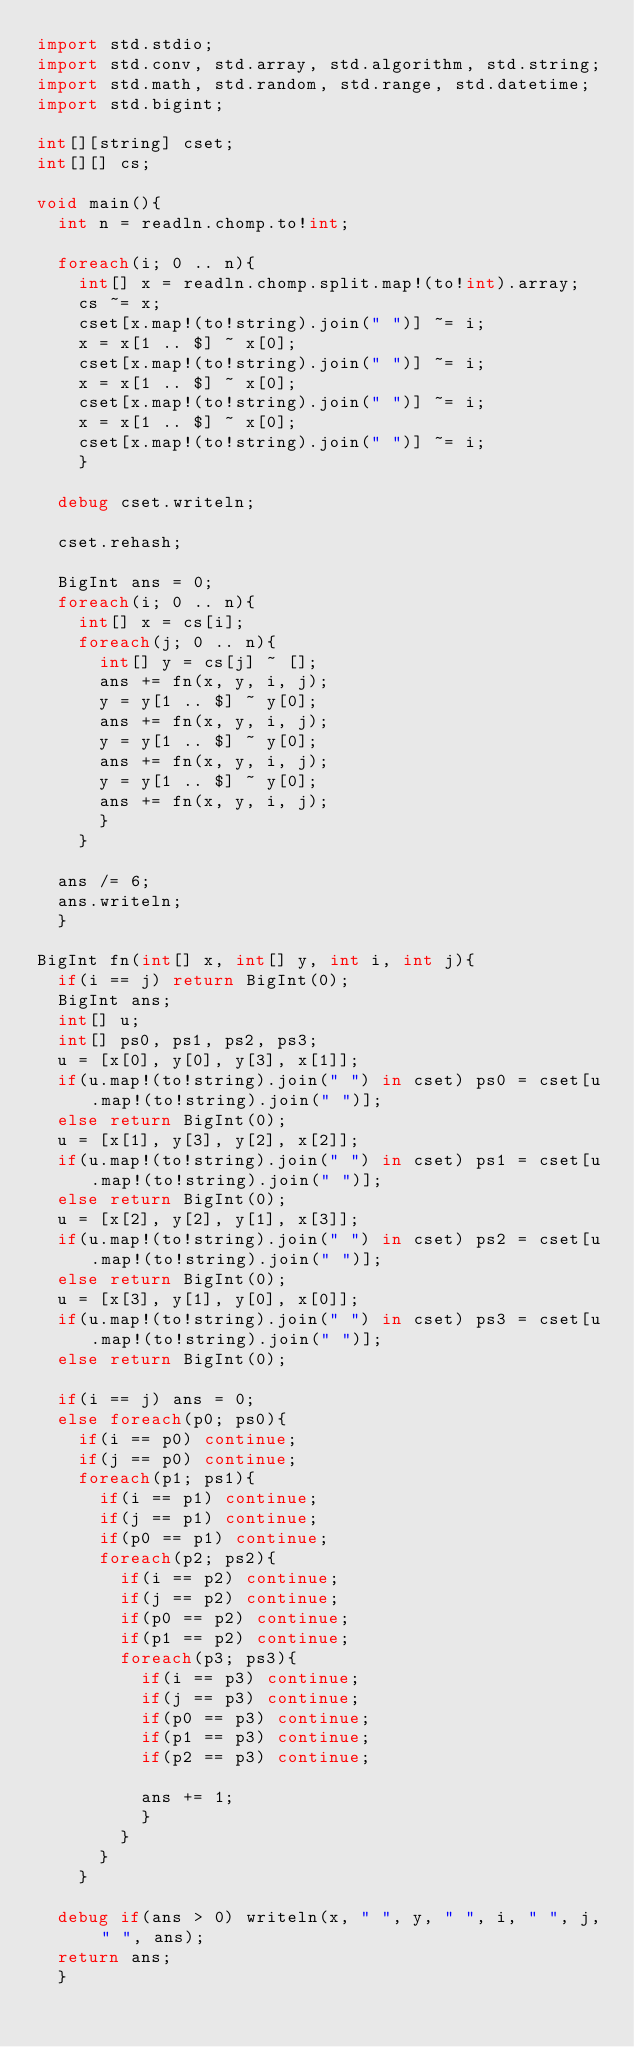Convert code to text. <code><loc_0><loc_0><loc_500><loc_500><_D_>import std.stdio;
import std.conv, std.array, std.algorithm, std.string;
import std.math, std.random, std.range, std.datetime;
import std.bigint;

int[][string] cset;
int[][] cs;

void main(){
	int n = readln.chomp.to!int;
	
	foreach(i; 0 .. n){
		int[] x = readln.chomp.split.map!(to!int).array;
		cs ~= x;
		cset[x.map!(to!string).join(" ")] ~= i;
		x = x[1 .. $] ~ x[0];
		cset[x.map!(to!string).join(" ")] ~= i;
		x = x[1 .. $] ~ x[0];
		cset[x.map!(to!string).join(" ")] ~= i;
		x = x[1 .. $] ~ x[0];
		cset[x.map!(to!string).join(" ")] ~= i;
		}
	
	debug cset.writeln;
	
	cset.rehash;
	
	BigInt ans = 0;
	foreach(i; 0 .. n){
		int[] x = cs[i];
		foreach(j; 0 .. n){
			int[] y = cs[j] ~ [];
			ans += fn(x, y, i, j);
			y = y[1 .. $] ~ y[0];
			ans += fn(x, y, i, j);
			y = y[1 .. $] ~ y[0];
			ans += fn(x, y, i, j);
			y = y[1 .. $] ~ y[0];
			ans += fn(x, y, i, j);
			}
		}
	
	ans /= 6;
	ans.writeln;
	}

BigInt fn(int[] x, int[] y, int i, int j){
	if(i == j) return BigInt(0);
	BigInt ans;
	int[] u;
	int[] ps0, ps1, ps2, ps3;
	u = [x[0], y[0], y[3], x[1]];
	if(u.map!(to!string).join(" ") in cset) ps0 = cset[u.map!(to!string).join(" ")];
	else return BigInt(0);
	u = [x[1], y[3], y[2], x[2]];
	if(u.map!(to!string).join(" ") in cset) ps1 = cset[u.map!(to!string).join(" ")];
	else return BigInt(0);
	u = [x[2], y[2], y[1], x[3]];
	if(u.map!(to!string).join(" ") in cset) ps2 = cset[u.map!(to!string).join(" ")];
	else return BigInt(0);
	u = [x[3], y[1], y[0], x[0]];
	if(u.map!(to!string).join(" ") in cset) ps3 = cset[u.map!(to!string).join(" ")];
	else return BigInt(0);
	
	if(i == j) ans = 0;
	else foreach(p0; ps0){
		if(i == p0) continue;
		if(j == p0) continue;
		foreach(p1; ps1){
			if(i == p1) continue;
			if(j == p1) continue;
			if(p0 == p1) continue;
			foreach(p2; ps2){
				if(i == p2) continue;
				if(j == p2) continue;
				if(p0 == p2) continue;
				if(p1 == p2) continue;
				foreach(p3; ps3){
					if(i == p3) continue;
					if(j == p3) continue;
					if(p0 == p3) continue;
					if(p1 == p3) continue;
					if(p2 == p3) continue;
					
					ans += 1;
					}
				}
			}
		}
	
	debug if(ans > 0) writeln(x, " ", y, " ", i, " ", j, " ", ans);
	return ans;
	}</code> 